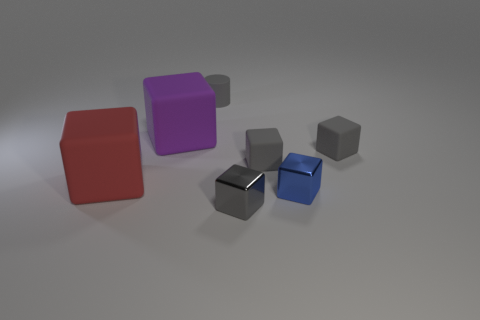Is the shape of the large purple object the same as the tiny blue metallic thing?
Provide a short and direct response. Yes. There is a large matte thing that is on the left side of the big rubber object that is behind the red rubber block; are there any tiny blue metal blocks that are behind it?
Keep it short and to the point. No. What number of tiny shiny things have the same color as the rubber cylinder?
Offer a very short reply. 1. What is the shape of the red object that is the same size as the purple matte cube?
Your answer should be very brief. Cube. There is a tiny blue metal cube; are there any tiny metal blocks right of it?
Your answer should be compact. No. Is the size of the blue block the same as the purple block?
Offer a terse response. No. What shape is the small gray thing in front of the blue object?
Your answer should be compact. Cube. Are there any purple shiny blocks that have the same size as the blue cube?
Your answer should be very brief. No. What material is the other cube that is the same size as the red matte block?
Provide a succinct answer. Rubber. There is a rubber cube that is on the left side of the large purple rubber thing; what size is it?
Ensure brevity in your answer.  Large. 